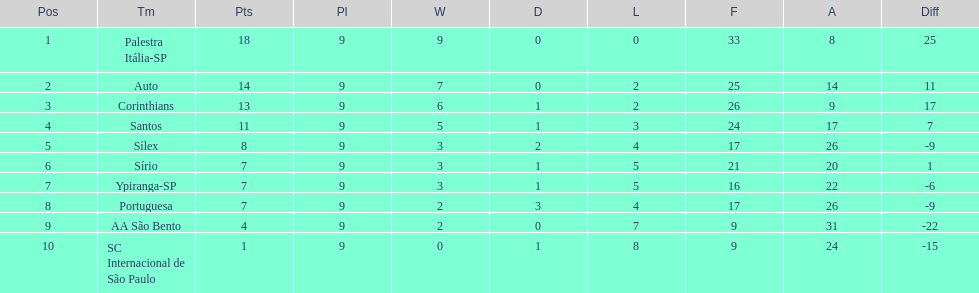Which team remained undefeated throughout the season? Palestra Itália-SP. 